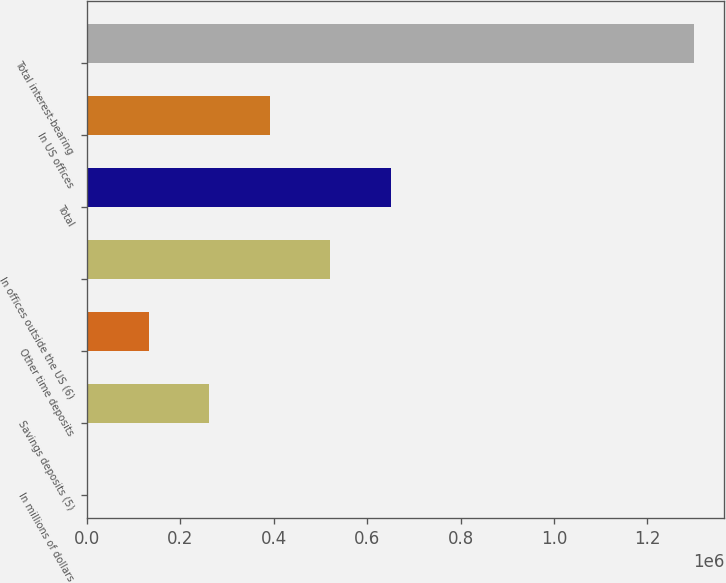Convert chart to OTSL. <chart><loc_0><loc_0><loc_500><loc_500><bar_chart><fcel>In millions of dollars<fcel>Savings deposits (5)<fcel>Other time deposits<fcel>In offices outside the US (6)<fcel>Total<fcel>In US offices<fcel>Total interest-bearing<nl><fcel>2006<fcel>261700<fcel>131853<fcel>521394<fcel>651242<fcel>391547<fcel>1.30048e+06<nl></chart> 